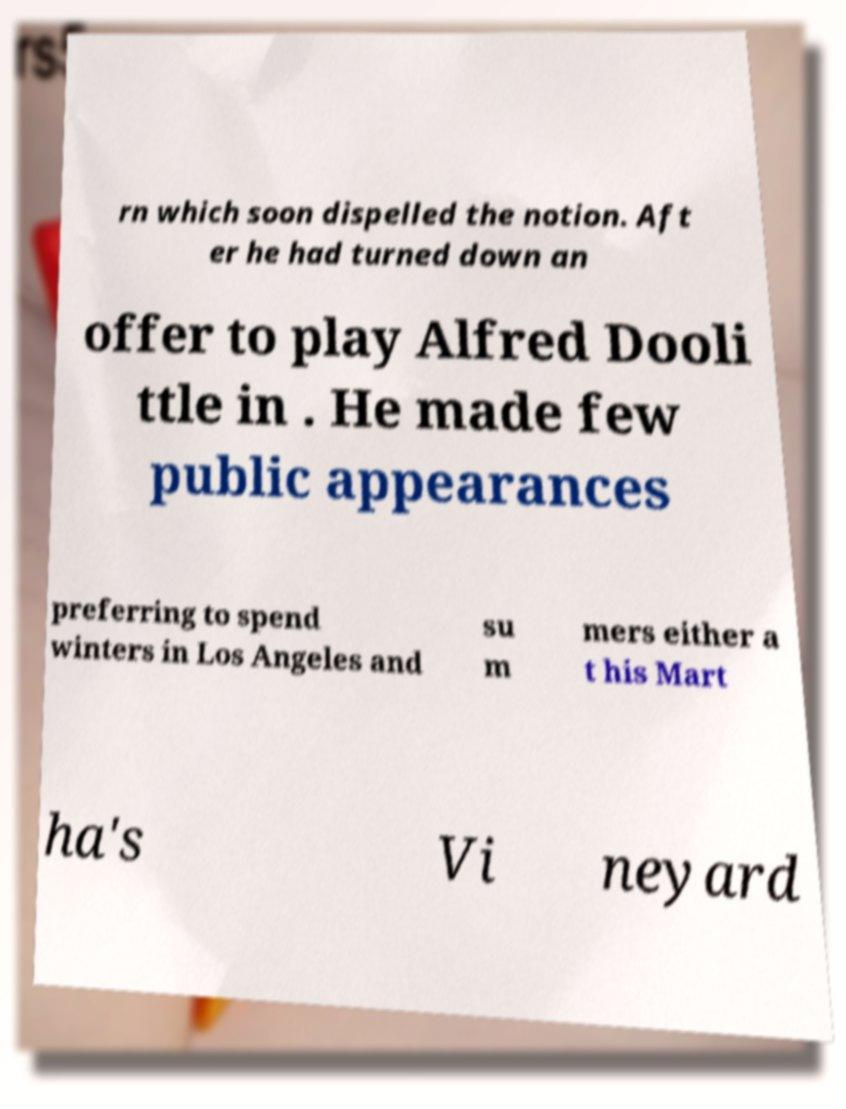I need the written content from this picture converted into text. Can you do that? rn which soon dispelled the notion. Aft er he had turned down an offer to play Alfred Dooli ttle in . He made few public appearances preferring to spend winters in Los Angeles and su m mers either a t his Mart ha's Vi neyard 